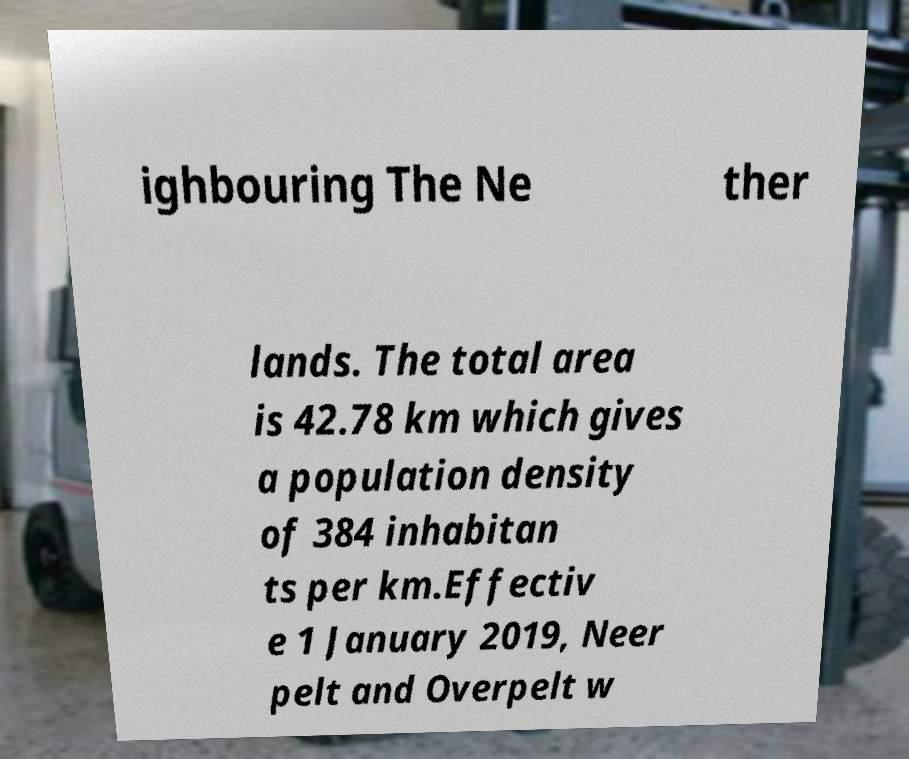I need the written content from this picture converted into text. Can you do that? ighbouring The Ne ther lands. The total area is 42.78 km which gives a population density of 384 inhabitan ts per km.Effectiv e 1 January 2019, Neer pelt and Overpelt w 